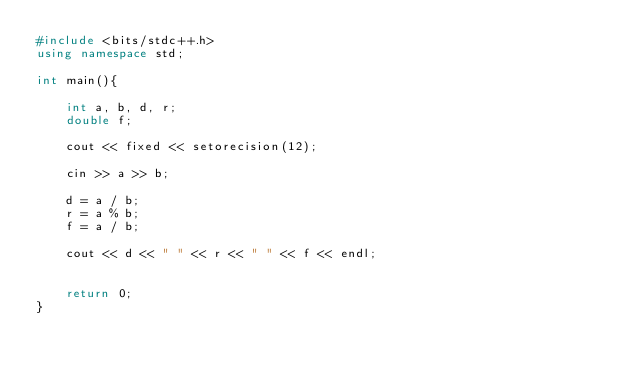Convert code to text. <code><loc_0><loc_0><loc_500><loc_500><_C++_>#include <bits/stdc++.h>
using namespace std;

int main(){
    
    int a, b, d, r;
    double f;
    
    cout << fixed << setorecision(12);
    
    cin >> a >> b;
    
    d = a / b;
    r = a % b;
    f = a / b;
    
    cout << d << " " << r << " " << f << endl;
    
    
    return 0;
}
</code> 